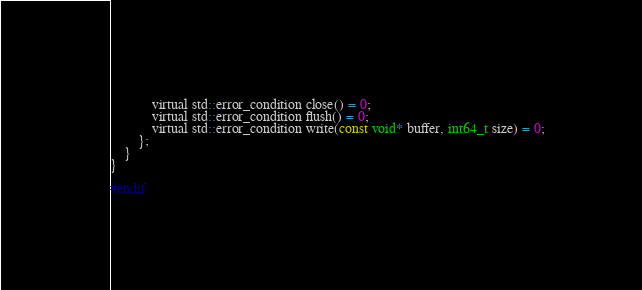<code> <loc_0><loc_0><loc_500><loc_500><_C_>
			virtual std::error_condition close() = 0;
			virtual std::error_condition flush() = 0;
			virtual std::error_condition write(const void* buffer, int64_t size) = 0;
		};
	}
}

#endif
</code> 